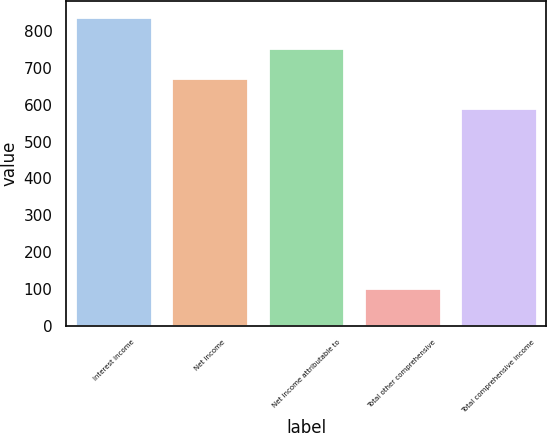Convert chart. <chart><loc_0><loc_0><loc_500><loc_500><bar_chart><fcel>Interest income<fcel>Net income<fcel>Net income attributable to<fcel>Total other comprehensive<fcel>Total comprehensive income<nl><fcel>839<fcel>671.6<fcel>753.4<fcel>102.8<fcel>589.8<nl></chart> 